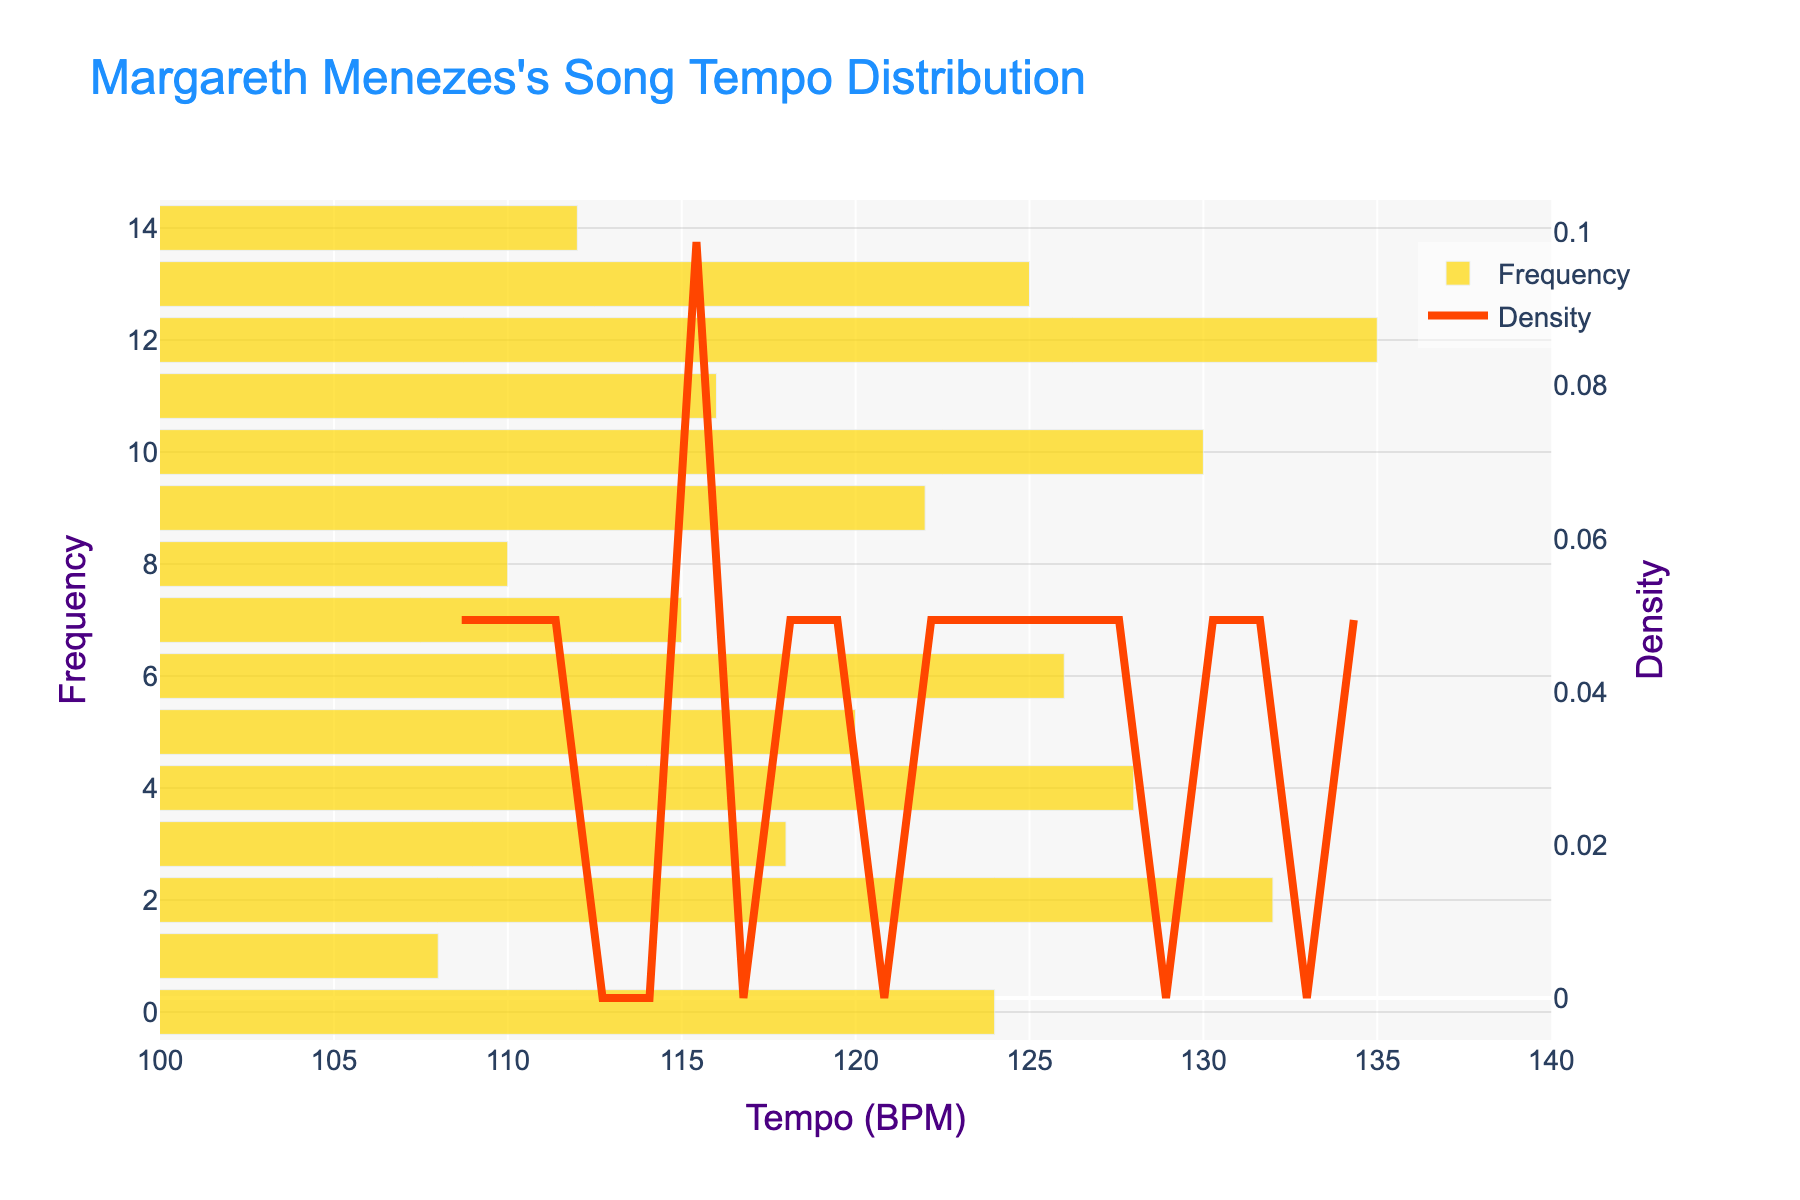What is the title of the figure? The title of the figure is located at the top and provides an overview of what the figure represents.
Answer: Margareth Menezes's Song Tempo Distribution What range of tempo in BPM is displayed on the x-axis? The x-axis displays the tempo in beats per minute (BPM), and you can see the range from the axis labels.
Answer: 100 to 140 BPM What does the yellow bar represent in the figure? The yellow bar in the figure corresponds to the frequency of songs at each tempo in beats per minute (BPM).
Answer: Frequency What does the red line represent in the figure? The red line in the figure represents the density estimation of the tempo distribution in beats per minute (BPM) for the songs.
Answer: Density Which tempo has the highest frequency? By observing the height of the yellow bars, you can identify the tempo at which the bar is the tallest.
Answer: Around 116 BPM At which tempo is the density curve at its peak? Look at the red line and find the tempo where it reaches its maximum height.
Answer: Around 116 BPM What is the approximate tempo range where most songs are concentrated? Observing both the histogram and the density curve, identify the range where the most notable frequencies and the highest density occur.
Answer: 110 to 130 BPM How many songs are there with a tempo of 130 BPM or higher? Count the number of yellow bars at or beyond the point where the tempo is 130 BPM.
Answer: 2 songs Is there a tempo that has both high frequency and high density? Identify any tempo that features both a tall yellow bar (high frequency) and a peak in the red density line.
Answer: Around 116 BPM What can you infer about Margareth Menezes's musical style diversity based on the tempo distribution? Analyze the spread of the tempo values and the shape of the density curve to determine how varied the bpm of her songs is. A wide range and varying densities indicate diversity.
Answer: Diverse 